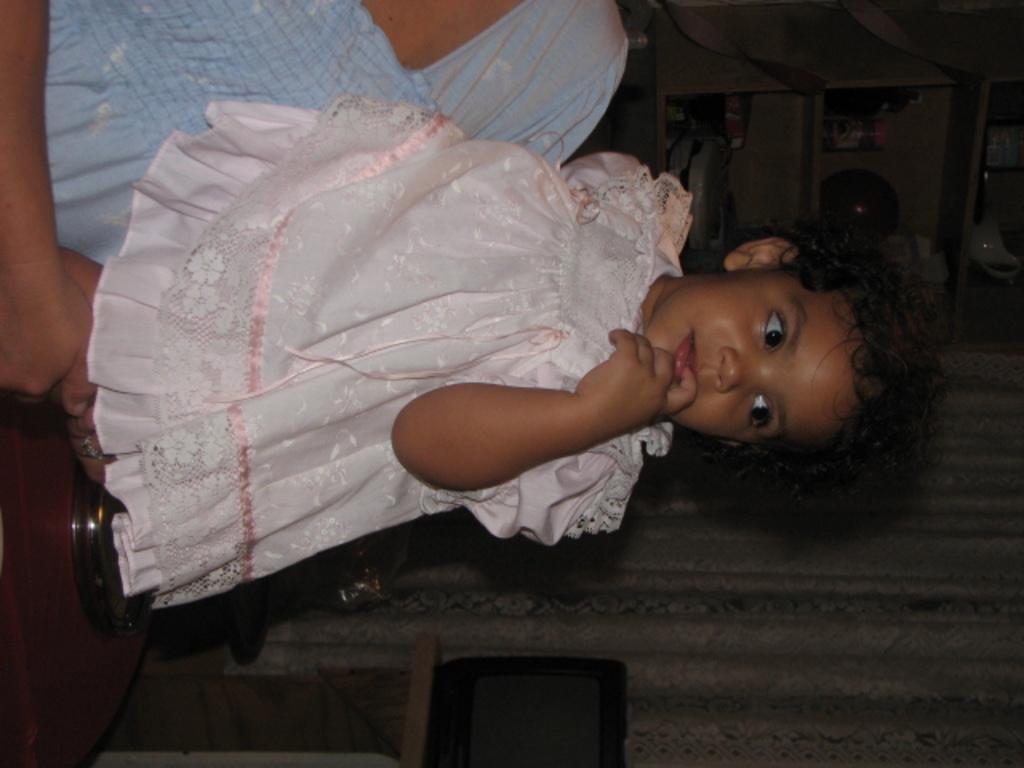In one or two sentences, can you explain what this image depicts? In the picture we can see a person holding a baby and she is in pink frock and behind her we can see a curtain and near it, we can see a table with a television and some racks on the other side with something are placed in it. 